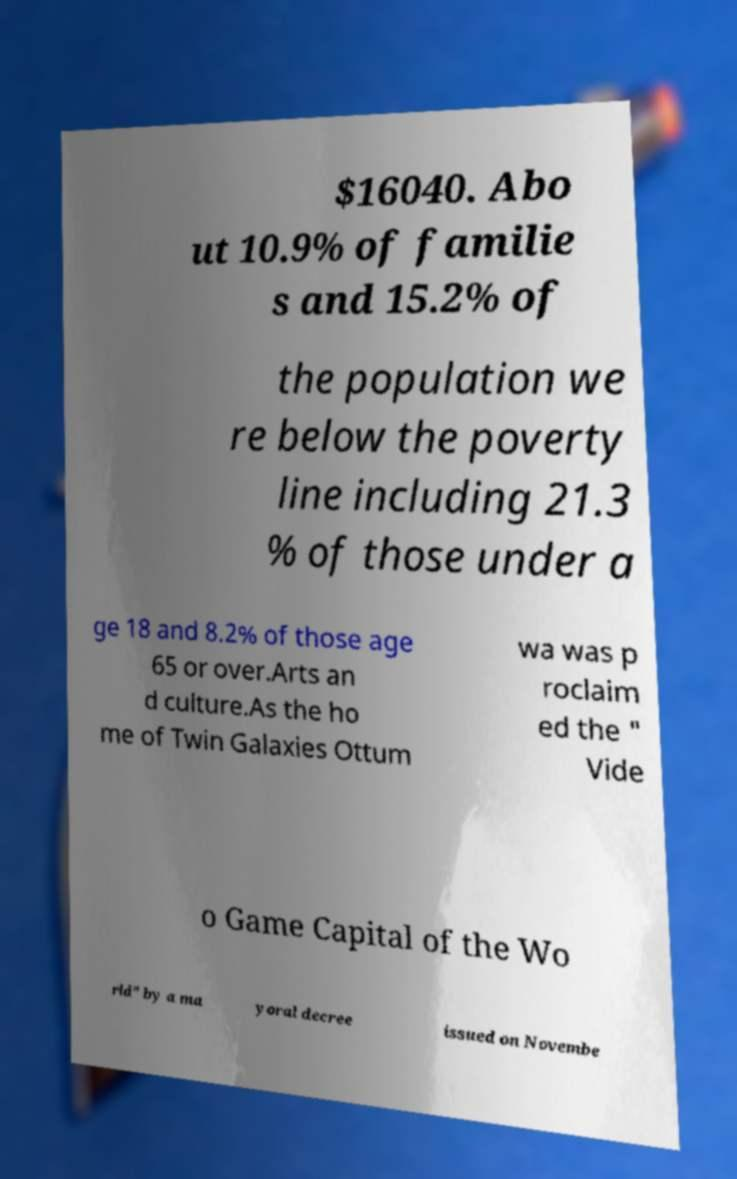For documentation purposes, I need the text within this image transcribed. Could you provide that? $16040. Abo ut 10.9% of familie s and 15.2% of the population we re below the poverty line including 21.3 % of those under a ge 18 and 8.2% of those age 65 or over.Arts an d culture.As the ho me of Twin Galaxies Ottum wa was p roclaim ed the " Vide o Game Capital of the Wo rld" by a ma yoral decree issued on Novembe 